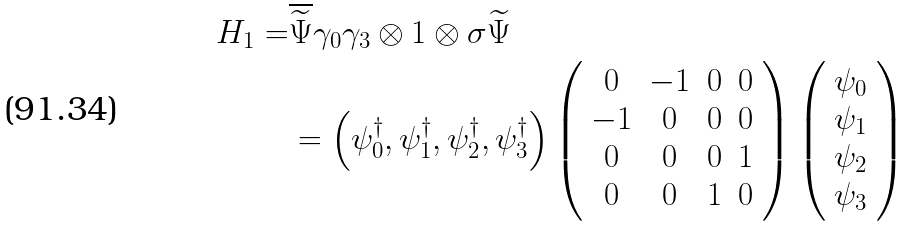<formula> <loc_0><loc_0><loc_500><loc_500>H _ { 1 } = & \overline { \widetilde { \Psi } } \gamma _ { 0 } \gamma _ { 3 } \otimes 1 \otimes \sigma \widetilde { \Psi } \\ & = \left ( \psi _ { 0 } ^ { \dag } , \psi _ { 1 } ^ { \dag } , \psi _ { 2 } ^ { \dag } , \psi _ { 3 } ^ { \dag } \right ) \left ( \begin{array} { c c c c } 0 & - 1 & 0 & 0 \\ - 1 & 0 & 0 & 0 \\ 0 & 0 & 0 & 1 \\ 0 & 0 & 1 & 0 \end{array} \right ) \left ( \begin{array} { c } \psi _ { 0 } \\ \psi _ { 1 } \\ \psi _ { 2 } \\ \psi _ { 3 } \end{array} \right )</formula> 